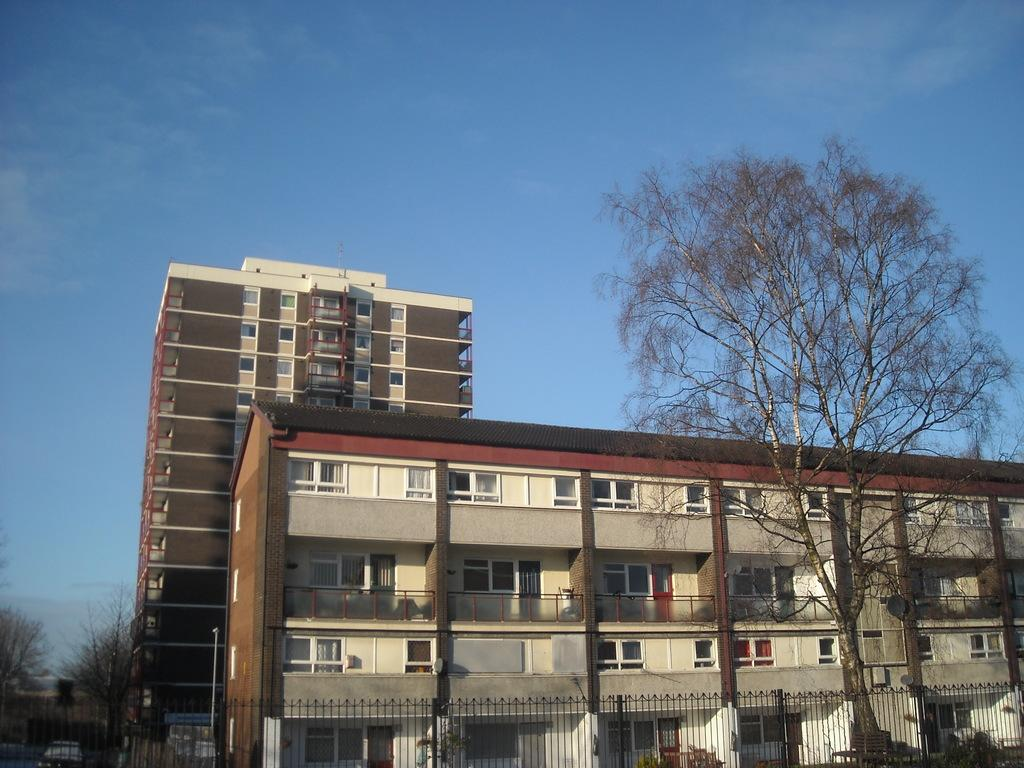What type of structures are present in the image? There are buildings in the image. What can be seen on the left side of the image? There are trees on the left side of the image. What can be seen on the right side of the image? There are trees on the right side of the image. What is visible at the top of the image? The sky is visible at the top of the image. What color is the sky in the image? The sky is blue in color. Can you see a collar on any of the trees in the image? There are no collars present on the trees in the image. What action is the frog performing in the image? There are no frogs present in the image. 